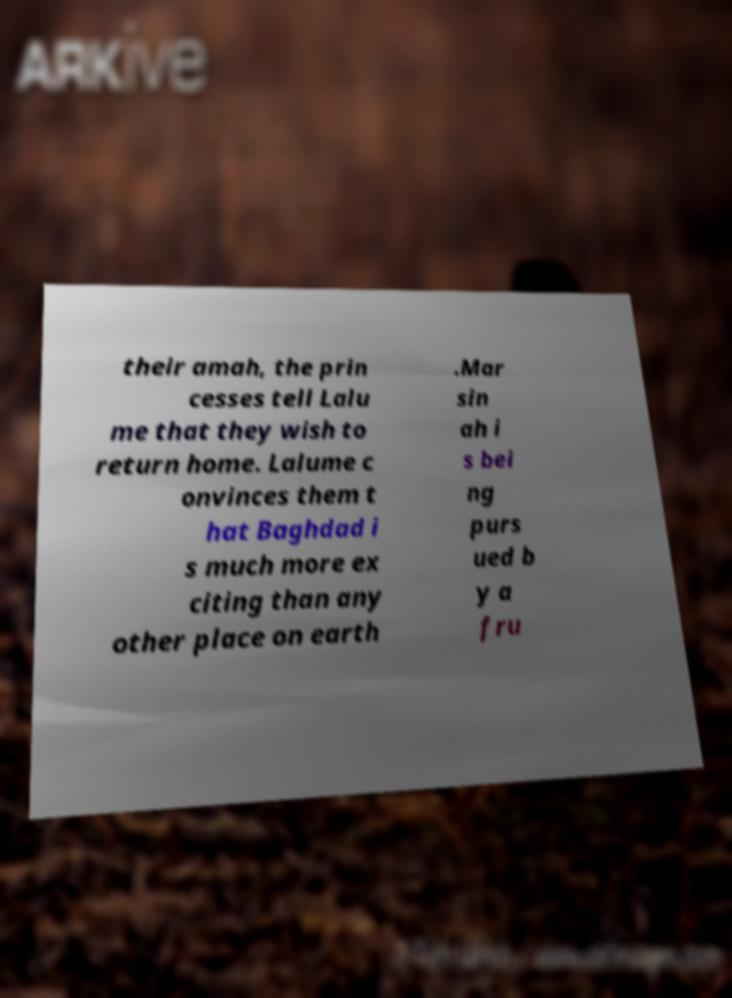Please identify and transcribe the text found in this image. their amah, the prin cesses tell Lalu me that they wish to return home. Lalume c onvinces them t hat Baghdad i s much more ex citing than any other place on earth .Mar sin ah i s bei ng purs ued b y a fru 